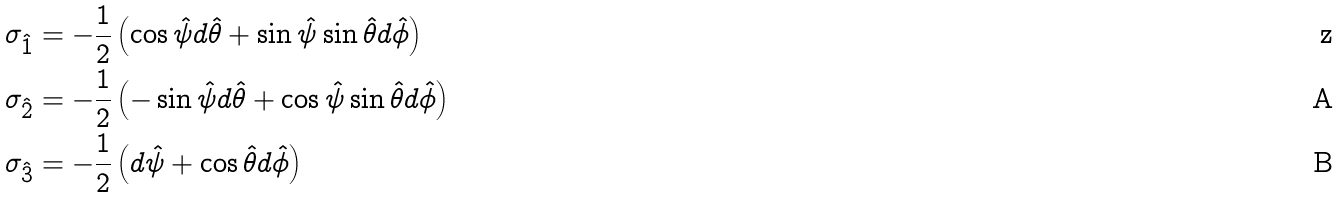Convert formula to latex. <formula><loc_0><loc_0><loc_500><loc_500>\sigma _ { \hat { 1 } } & = - \frac { 1 } { 2 } \left ( \cos \hat { \psi } d \hat { \theta } + \sin \hat { \psi } \sin \hat { \theta } d \hat { \phi } \right ) \\ \sigma _ { \hat { 2 } } & = - \frac { 1 } { 2 } \left ( - \sin \hat { \psi } d \hat { \theta } + \cos \hat { \psi } \sin \hat { \theta } d \hat { \phi } \right ) \\ \sigma _ { \hat { 3 } } & = - \frac { 1 } { 2 } \left ( d \hat { \psi } + \cos \hat { \theta } d \hat { \phi } \right )</formula> 